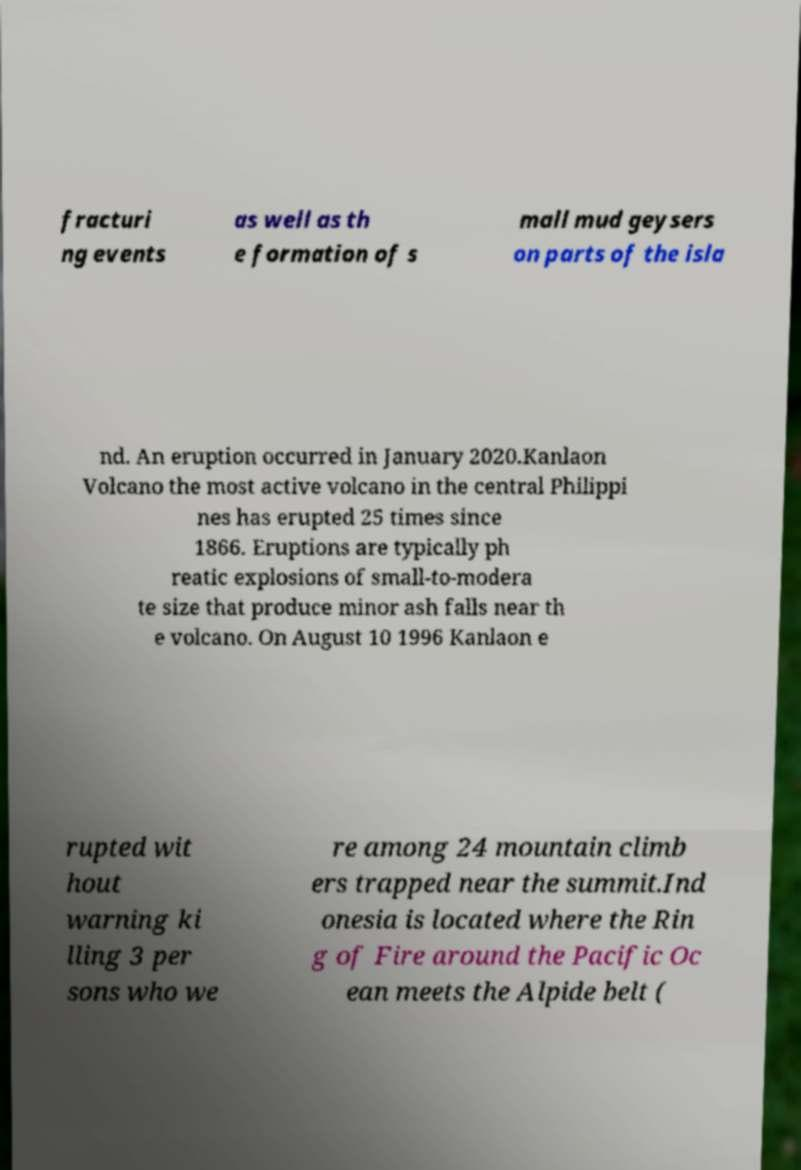Could you assist in decoding the text presented in this image and type it out clearly? fracturi ng events as well as th e formation of s mall mud geysers on parts of the isla nd. An eruption occurred in January 2020.Kanlaon Volcano the most active volcano in the central Philippi nes has erupted 25 times since 1866. Eruptions are typically ph reatic explosions of small-to-modera te size that produce minor ash falls near th e volcano. On August 10 1996 Kanlaon e rupted wit hout warning ki lling 3 per sons who we re among 24 mountain climb ers trapped near the summit.Ind onesia is located where the Rin g of Fire around the Pacific Oc ean meets the Alpide belt ( 